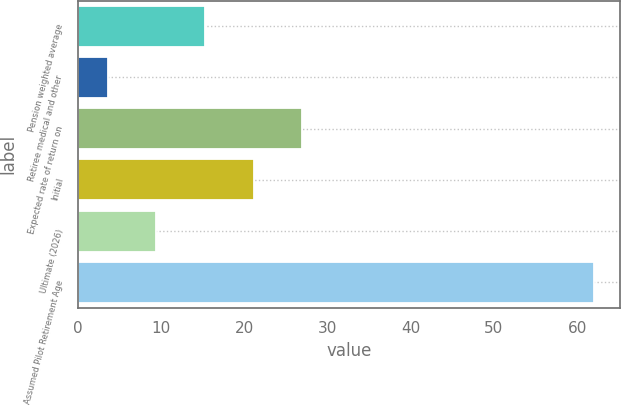Convert chart to OTSL. <chart><loc_0><loc_0><loc_500><loc_500><bar_chart><fcel>Pension weighted average<fcel>Retiree medical and other<fcel>Expected rate of return on<fcel>Initial<fcel>Ultimate (2026)<fcel>Assumed Pilot Retirement Age<nl><fcel>15.28<fcel>3.6<fcel>26.96<fcel>21.12<fcel>9.44<fcel>62<nl></chart> 